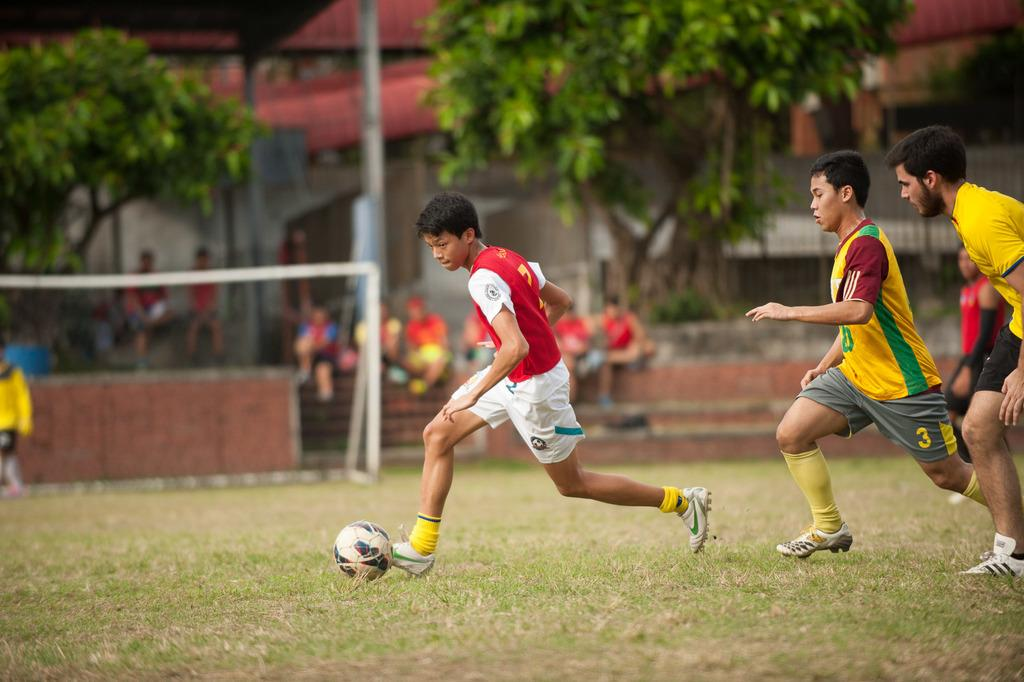<image>
Offer a succinct explanation of the picture presented. Young men are playing soccer in a field and one has a 3 on his shorts. 